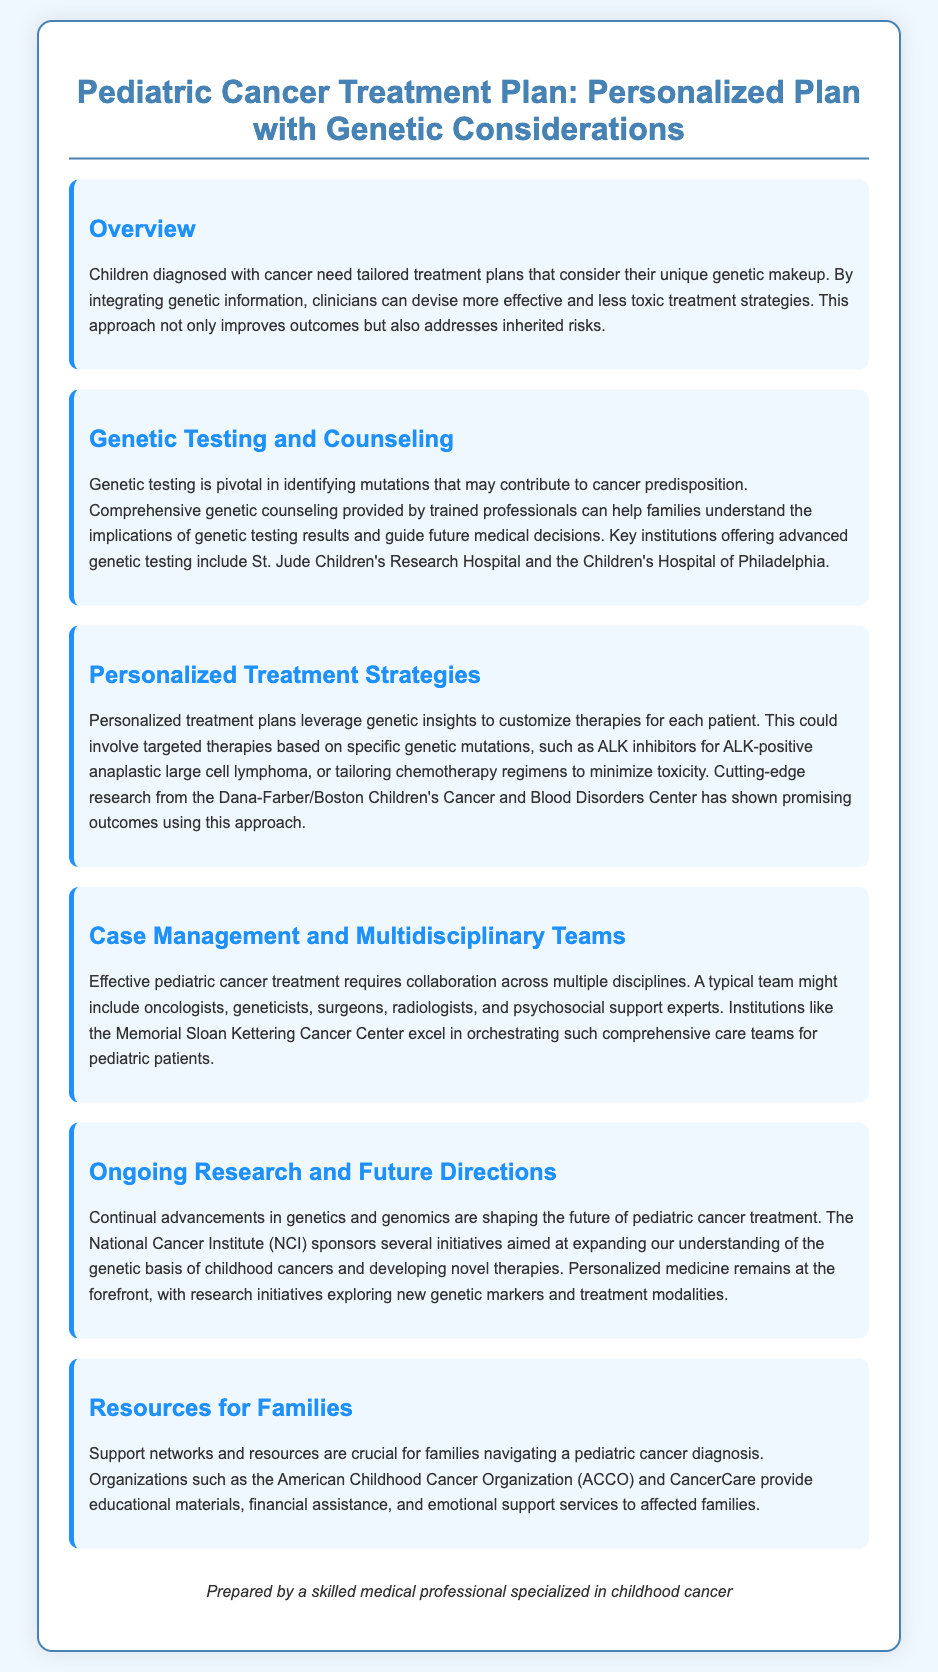What is the main focus of the treatment plan? The document emphasizes the need for tailored treatment plans that consider children’s unique genetic makeup, integrating genetic information for better outcomes.
Answer: tailored treatment plans Which institution is mentioned as offering advanced genetic testing? The document specifically names St. Jude Children's Research Hospital as one of the key institutions providing advanced genetic testing.
Answer: St. Jude Children's Research Hospital What kind of therapies might be customized based on genetic insights? The document mentions targeted therapies based on specific mutations, like ALK inhibitors for ALK-positive anaplastic large cell lymphoma.
Answer: ALK inhibitors Who collaborates in pediatric cancer treatment? A typical team for pediatric cancer treatment includes oncologists, geneticists, surgeons, radiologists, and psychosocial support experts.
Answer: multidisciplinary team What does ongoing research focus on according to the document? The document states that ongoing research sponsored by the NCI focuses on expanding understanding of genetic basis of childhood cancers and developing novel therapies.
Answer: genetic basis of childhood cancers What type of support is offered by the American Childhood Cancer Organization? The document indicates that the ACCO provides educational materials, financial assistance, and emotional support services to families.
Answer: educational materials, financial assistance, emotional support What is a goal of genetic counseling mentioned in the document? The document mentions that genetic counseling aims to help families understand the implications of genetic testing results and guide medical decisions.
Answer: guide future medical decisions What is considered at the forefront of ongoing research? The document specifies that personalized medicine remains at the forefront, with initiatives exploring new genetic markers and treatment modalities.
Answer: personalized medicine 